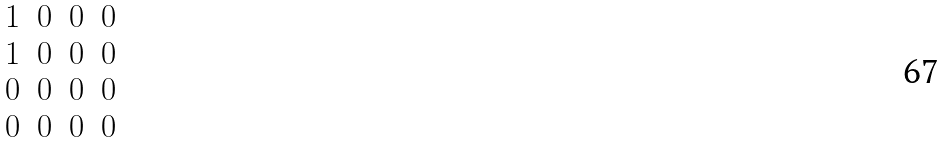Convert formula to latex. <formula><loc_0><loc_0><loc_500><loc_500>\begin{matrix} 1 & 0 & 0 & 0 \\ 1 & 0 & 0 & 0 \\ 0 & 0 & 0 & 0 \\ 0 & 0 & 0 & 0 \end{matrix}</formula> 